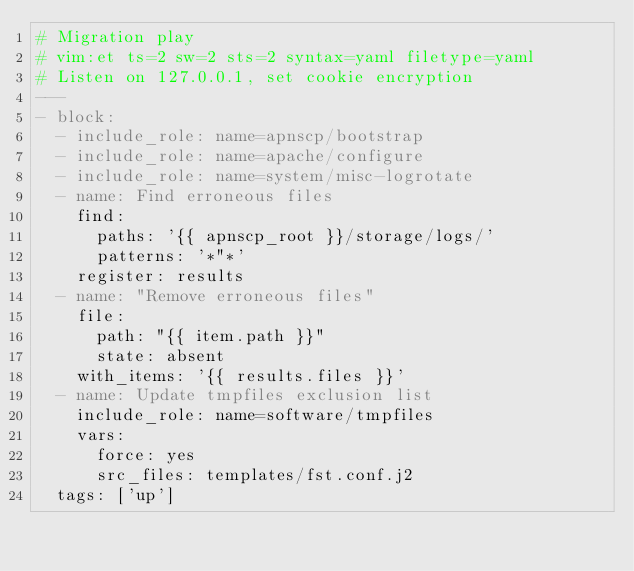<code> <loc_0><loc_0><loc_500><loc_500><_YAML_># Migration play
# vim:et ts=2 sw=2 sts=2 syntax=yaml filetype=yaml
# Listen on 127.0.0.1, set cookie encryption
---
- block:
  - include_role: name=apnscp/bootstrap
  - include_role: name=apache/configure
  - include_role: name=system/misc-logrotate
  - name: Find erroneous files
    find:
      paths: '{{ apnscp_root }}/storage/logs/'
      patterns: '*"*'
    register: results
  - name: "Remove erroneous files"
    file:
      path: "{{ item.path }}"
      state: absent
    with_items: '{{ results.files }}'
  - name: Update tmpfiles exclusion list
    include_role: name=software/tmpfiles
    vars:
      force: yes
      src_files: templates/fst.conf.j2
  tags: ['up']
</code> 